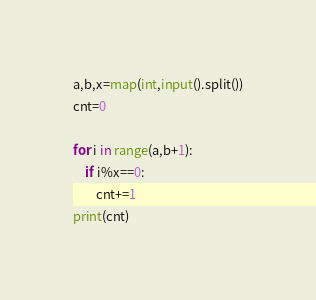<code> <loc_0><loc_0><loc_500><loc_500><_Python_>a,b,x=map(int,input().split())
cnt=0

for i in range(a,b+1):
    if i%x==0:
        cnt+=1
print(cnt)</code> 